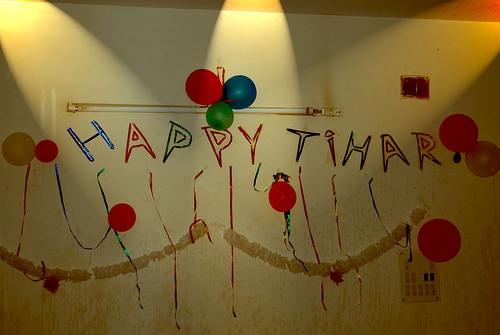<image>
Is there a bulb on the baloon? No. The bulb is not positioned on the baloon. They may be near each other, but the bulb is not supported by or resting on top of the baloon. 